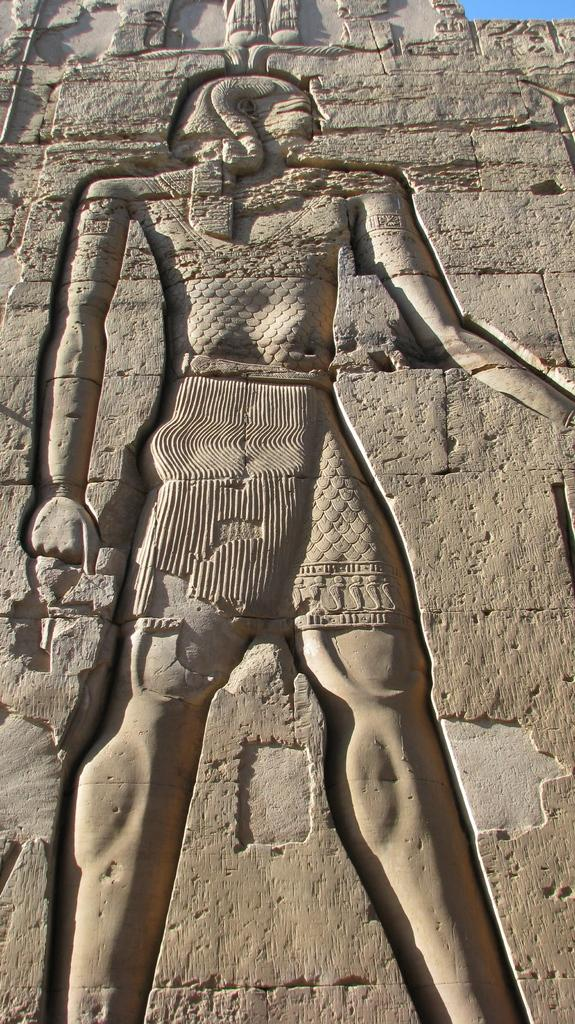What is on the wall in the image? There is a sculpture on a wall in the image. What can be seen in the background of the image? The sky is blue in the background of the image. What type of smoke is coming from the sculpture in the image? There is no smoke coming from the sculpture in the image. What role does the minister play in the image? There is no minister present in the image. 